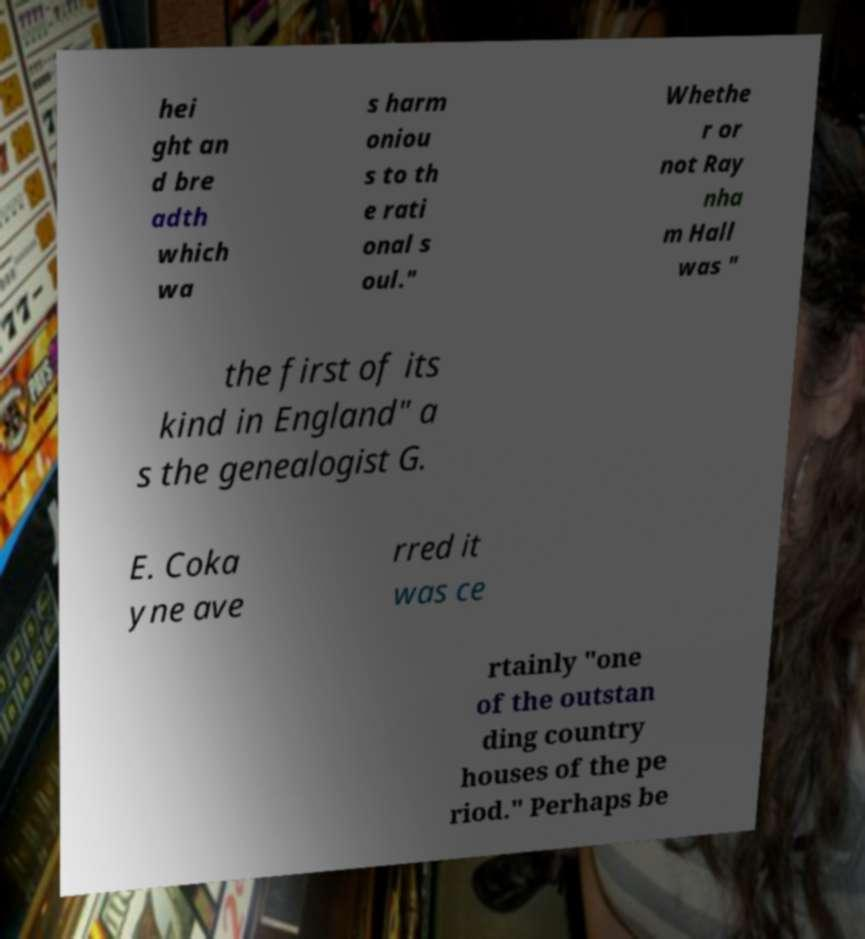Please identify and transcribe the text found in this image. hei ght an d bre adth which wa s harm oniou s to th e rati onal s oul." Whethe r or not Ray nha m Hall was " the first of its kind in England" a s the genealogist G. E. Coka yne ave rred it was ce rtainly "one of the outstan ding country houses of the pe riod." Perhaps be 